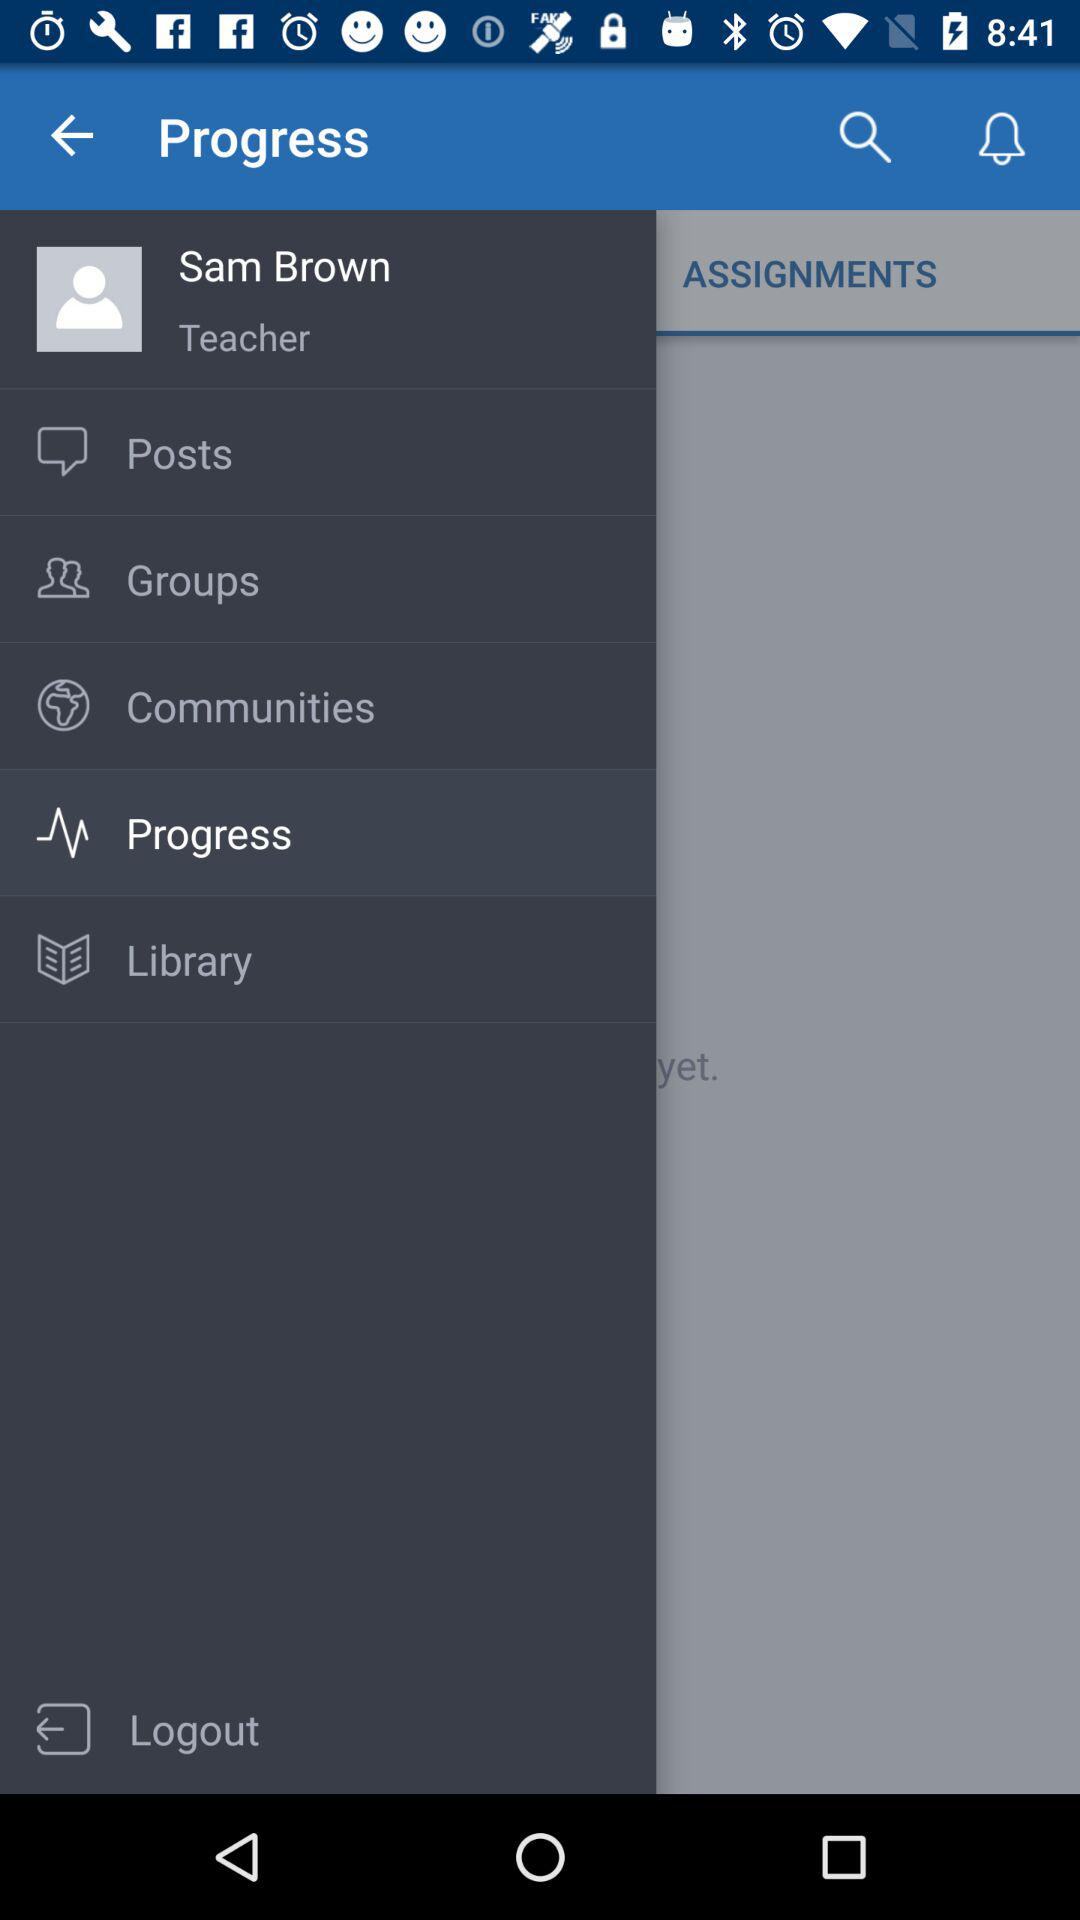What is the name of the user? The name of the user is Sam Brown. 